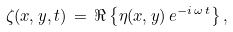<formula> <loc_0><loc_0><loc_500><loc_500>\zeta ( x , y , t ) \, = \, \Re \left \{ \eta ( x , y ) \, { e } ^ { - i \, \omega \, t } \right \} ,</formula> 